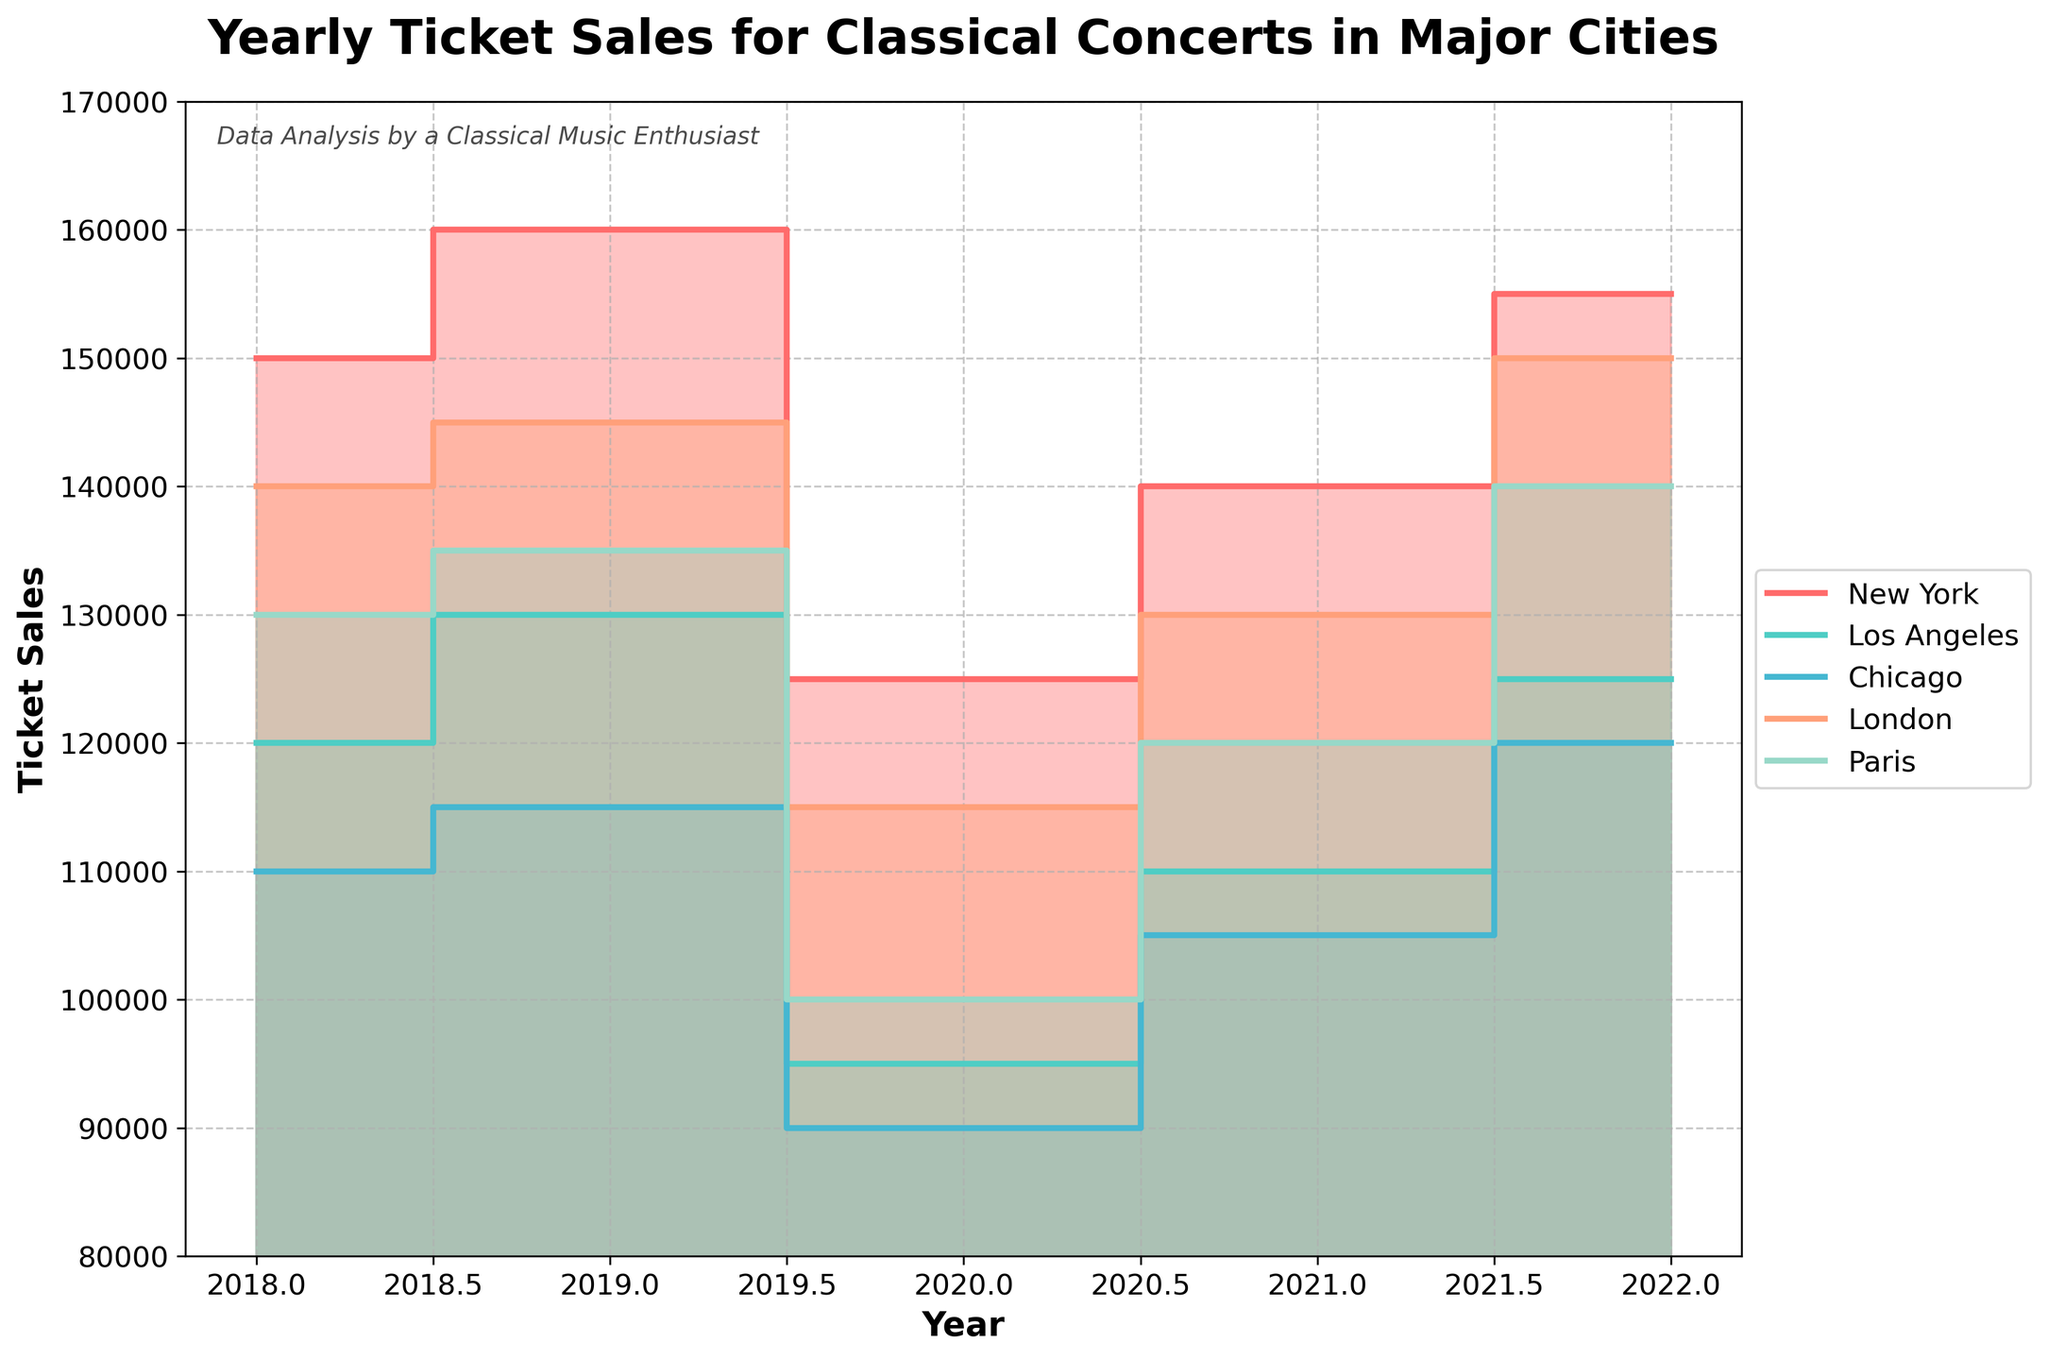What is the title of the chart? The title is clearly displayed at the top of the chart.
Answer: Yearly Ticket Sales for Classical Concerts in Major Cities Which city had the highest ticket sales in 2022? By examining the endpoint of each city's step area plot for 2022, we notice that London had the highest sales point.
Answer: London What is the range of the y-axis? The y-axis starts at 80,000 and ends at 170,000, as indicated by the labels.
Answer: 80,000 to 170,000 Compare the ticket sales of New York and Los Angeles in 2020. Who sold more tickets? The step areas of each city in 2020 indicate that New York's ticket sales were higher than Los Angeles'. New York sold 125,000 tickets, while Los Angeles sold 95,000.
Answer: New York What is the general trend of ticket sales for Chicago from 2018 to 2022? Observing the step area for Chicago, we see a dip in 2020 followed by a steady rise from 2021 to 2022, indicating a recovery.
Answer: Decrease then increase Which year did ticket sales drop significantly across all cities? All cities show a significant drop in their step areas around the year 2020.
Answer: 2020 How do Paris's ticket sales in 2018 compare to its ticket sales in 2021? Paris sold 130,000 tickets in 2018 and 120,000 tickets in 2021, showing a decrease.
Answer: Decrease Determine the average ticket sales for New York over the years presented. Summing New York's ticket sales (150,000 + 160,000 + 125,000 + 140,000 + 155,000) and dividing by 5 yields 146,000.
Answer: 146,000 Which city shows a complete recovery and even increase in ticket sales by 2022 compared to 2019? London sales in 2022 (150,000) exceed 2019 sales (145,000), indicating a full recovery and increase.
Answer: London Between 2018 and 2021, which city had the most consistent ticket sales trajectory (no large fluctuations)? By evaluating the step areas' fluctuations, Chicago has the most consistent trajectory, with only minor changes across the years.
Answer: Chicago 